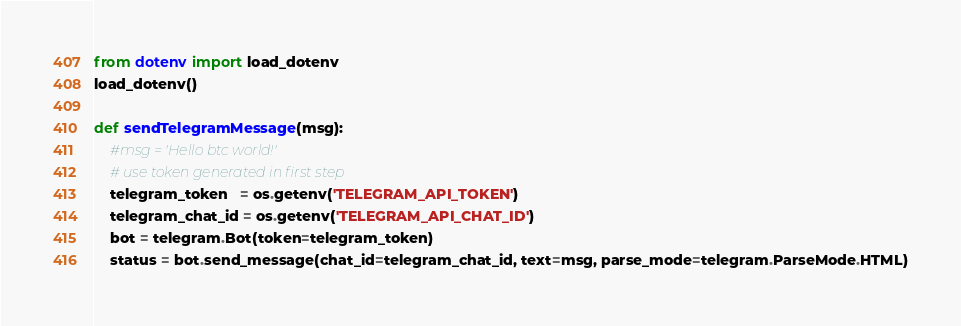Convert code to text. <code><loc_0><loc_0><loc_500><loc_500><_Python_>from dotenv import load_dotenv
load_dotenv()

def sendTelegramMessage(msg):
    #msg = 'Hello btc world!'
    # use token generated in first step
    telegram_token   = os.getenv('TELEGRAM_API_TOKEN')
    telegram_chat_id = os.getenv('TELEGRAM_API_CHAT_ID')
    bot = telegram.Bot(token=telegram_token)
    status = bot.send_message(chat_id=telegram_chat_id, text=msg, parse_mode=telegram.ParseMode.HTML)</code> 